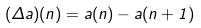<formula> <loc_0><loc_0><loc_500><loc_500>( \Delta a ) ( n ) = a ( n ) - a ( n + 1 )</formula> 